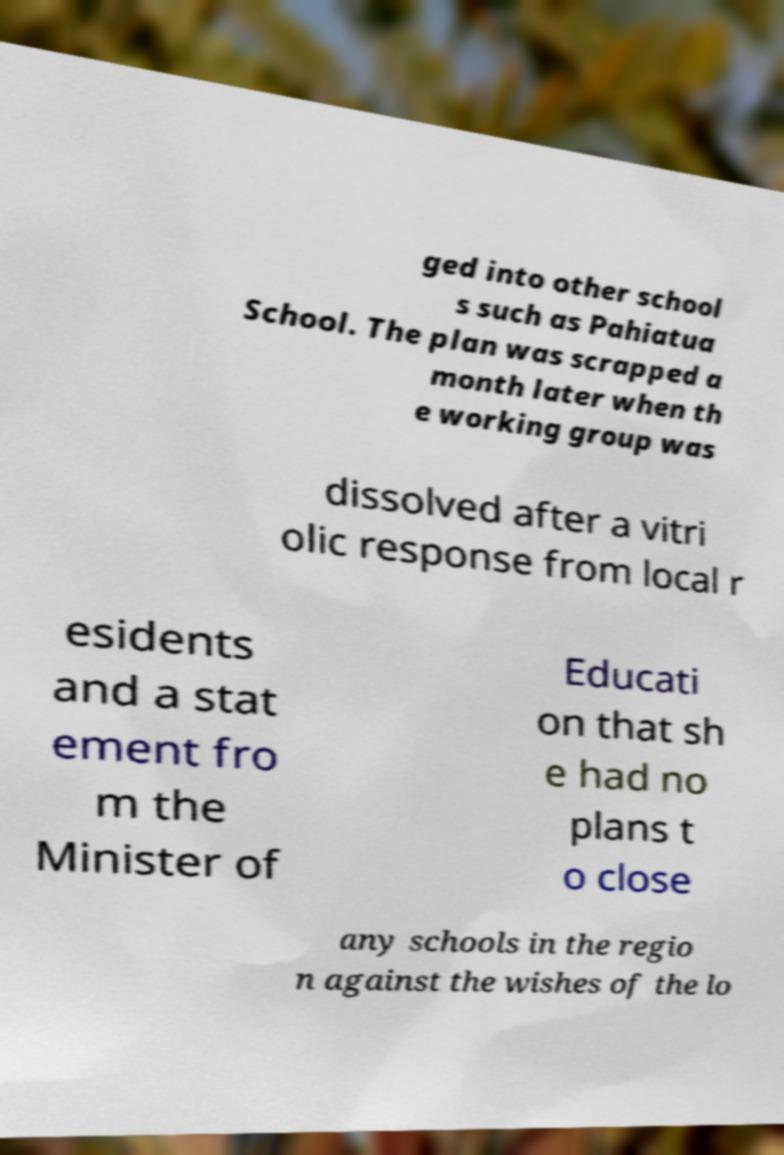What messages or text are displayed in this image? I need them in a readable, typed format. ged into other school s such as Pahiatua School. The plan was scrapped a month later when th e working group was dissolved after a vitri olic response from local r esidents and a stat ement fro m the Minister of Educati on that sh e had no plans t o close any schools in the regio n against the wishes of the lo 